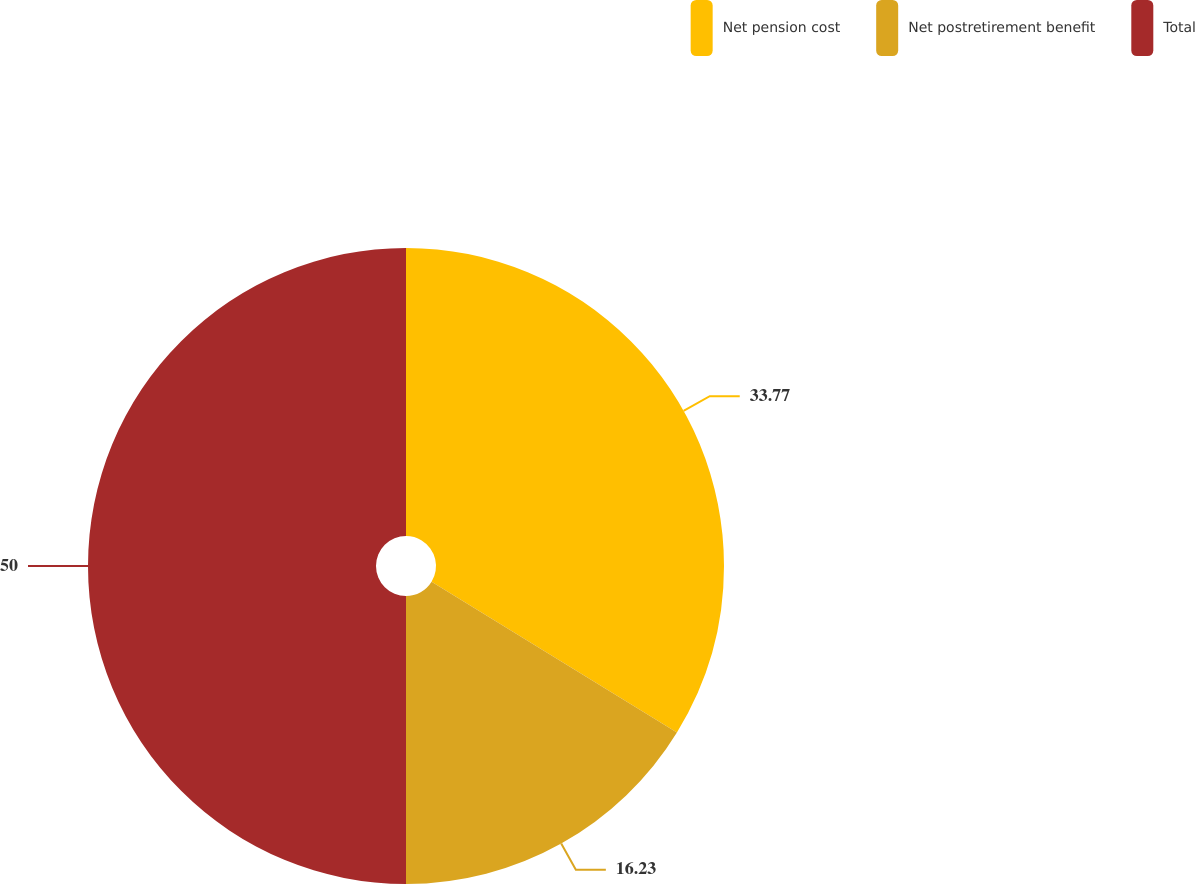Convert chart. <chart><loc_0><loc_0><loc_500><loc_500><pie_chart><fcel>Net pension cost<fcel>Net postretirement benefit<fcel>Total<nl><fcel>33.77%<fcel>16.23%<fcel>50.0%<nl></chart> 